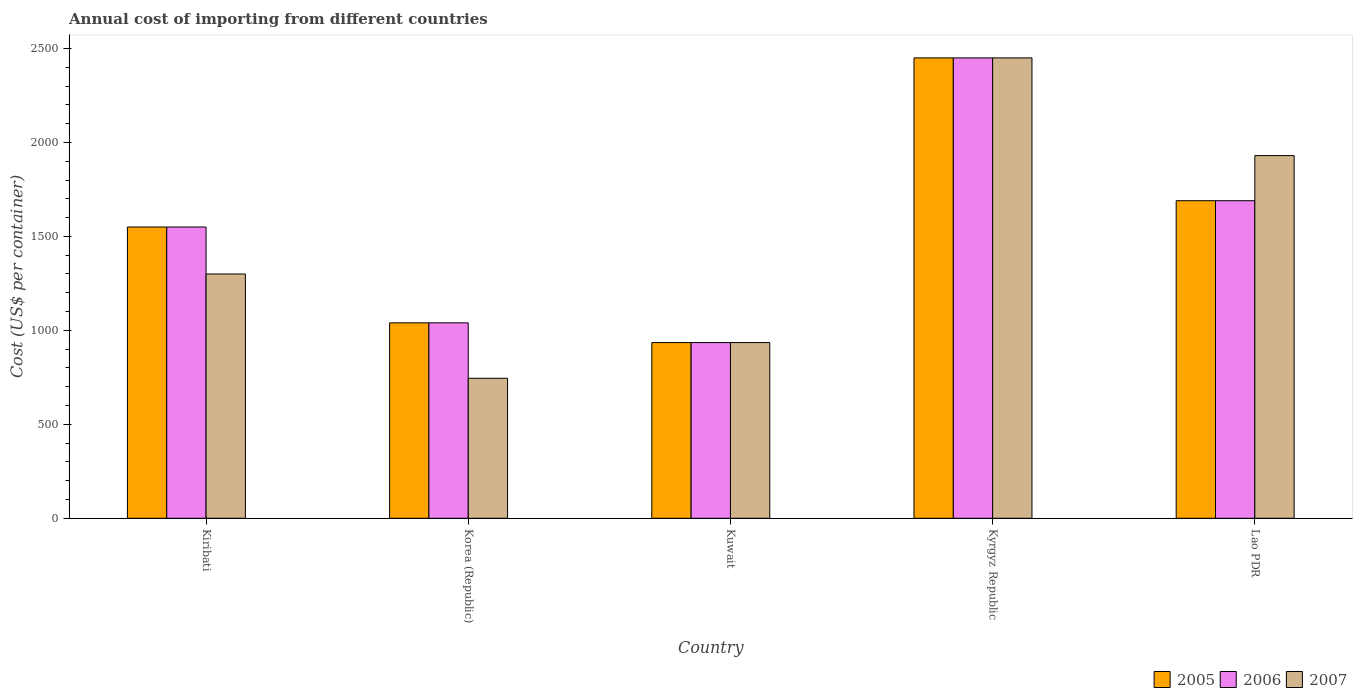How many different coloured bars are there?
Make the answer very short. 3. What is the total annual cost of importing in 2006 in Kyrgyz Republic?
Keep it short and to the point. 2450. Across all countries, what is the maximum total annual cost of importing in 2007?
Your answer should be compact. 2450. Across all countries, what is the minimum total annual cost of importing in 2006?
Provide a short and direct response. 935. In which country was the total annual cost of importing in 2007 maximum?
Ensure brevity in your answer.  Kyrgyz Republic. In which country was the total annual cost of importing in 2006 minimum?
Offer a very short reply. Kuwait. What is the total total annual cost of importing in 2007 in the graph?
Provide a succinct answer. 7360. What is the difference between the total annual cost of importing in 2006 in Korea (Republic) and that in Kuwait?
Make the answer very short. 105. What is the difference between the total annual cost of importing in 2006 in Kuwait and the total annual cost of importing in 2007 in Kiribati?
Give a very brief answer. -365. What is the average total annual cost of importing in 2005 per country?
Provide a succinct answer. 1533. What is the difference between the total annual cost of importing of/in 2006 and total annual cost of importing of/in 2005 in Kuwait?
Keep it short and to the point. 0. What is the ratio of the total annual cost of importing in 2007 in Kiribati to that in Korea (Republic)?
Offer a very short reply. 1.74. Is the difference between the total annual cost of importing in 2006 in Korea (Republic) and Kyrgyz Republic greater than the difference between the total annual cost of importing in 2005 in Korea (Republic) and Kyrgyz Republic?
Your response must be concise. No. What is the difference between the highest and the second highest total annual cost of importing in 2005?
Your answer should be very brief. 900. What is the difference between the highest and the lowest total annual cost of importing in 2005?
Make the answer very short. 1515. In how many countries, is the total annual cost of importing in 2007 greater than the average total annual cost of importing in 2007 taken over all countries?
Your answer should be compact. 2. How many legend labels are there?
Provide a short and direct response. 3. How are the legend labels stacked?
Make the answer very short. Horizontal. What is the title of the graph?
Your response must be concise. Annual cost of importing from different countries. Does "1961" appear as one of the legend labels in the graph?
Your answer should be compact. No. What is the label or title of the Y-axis?
Ensure brevity in your answer.  Cost (US$ per container). What is the Cost (US$ per container) in 2005 in Kiribati?
Your answer should be very brief. 1550. What is the Cost (US$ per container) in 2006 in Kiribati?
Provide a short and direct response. 1550. What is the Cost (US$ per container) in 2007 in Kiribati?
Keep it short and to the point. 1300. What is the Cost (US$ per container) in 2005 in Korea (Republic)?
Keep it short and to the point. 1040. What is the Cost (US$ per container) of 2006 in Korea (Republic)?
Offer a very short reply. 1040. What is the Cost (US$ per container) of 2007 in Korea (Republic)?
Keep it short and to the point. 745. What is the Cost (US$ per container) of 2005 in Kuwait?
Give a very brief answer. 935. What is the Cost (US$ per container) of 2006 in Kuwait?
Keep it short and to the point. 935. What is the Cost (US$ per container) of 2007 in Kuwait?
Your answer should be compact. 935. What is the Cost (US$ per container) of 2005 in Kyrgyz Republic?
Offer a very short reply. 2450. What is the Cost (US$ per container) in 2006 in Kyrgyz Republic?
Ensure brevity in your answer.  2450. What is the Cost (US$ per container) in 2007 in Kyrgyz Republic?
Your answer should be compact. 2450. What is the Cost (US$ per container) of 2005 in Lao PDR?
Offer a very short reply. 1690. What is the Cost (US$ per container) of 2006 in Lao PDR?
Provide a short and direct response. 1690. What is the Cost (US$ per container) in 2007 in Lao PDR?
Your answer should be compact. 1930. Across all countries, what is the maximum Cost (US$ per container) of 2005?
Offer a terse response. 2450. Across all countries, what is the maximum Cost (US$ per container) of 2006?
Provide a short and direct response. 2450. Across all countries, what is the maximum Cost (US$ per container) of 2007?
Provide a short and direct response. 2450. Across all countries, what is the minimum Cost (US$ per container) in 2005?
Your response must be concise. 935. Across all countries, what is the minimum Cost (US$ per container) in 2006?
Your answer should be very brief. 935. Across all countries, what is the minimum Cost (US$ per container) of 2007?
Keep it short and to the point. 745. What is the total Cost (US$ per container) of 2005 in the graph?
Keep it short and to the point. 7665. What is the total Cost (US$ per container) of 2006 in the graph?
Make the answer very short. 7665. What is the total Cost (US$ per container) in 2007 in the graph?
Offer a very short reply. 7360. What is the difference between the Cost (US$ per container) of 2005 in Kiribati and that in Korea (Republic)?
Your response must be concise. 510. What is the difference between the Cost (US$ per container) of 2006 in Kiribati and that in Korea (Republic)?
Your answer should be very brief. 510. What is the difference between the Cost (US$ per container) in 2007 in Kiribati and that in Korea (Republic)?
Your response must be concise. 555. What is the difference between the Cost (US$ per container) in 2005 in Kiribati and that in Kuwait?
Ensure brevity in your answer.  615. What is the difference between the Cost (US$ per container) in 2006 in Kiribati and that in Kuwait?
Keep it short and to the point. 615. What is the difference between the Cost (US$ per container) of 2007 in Kiribati and that in Kuwait?
Offer a very short reply. 365. What is the difference between the Cost (US$ per container) in 2005 in Kiribati and that in Kyrgyz Republic?
Your answer should be compact. -900. What is the difference between the Cost (US$ per container) of 2006 in Kiribati and that in Kyrgyz Republic?
Provide a succinct answer. -900. What is the difference between the Cost (US$ per container) in 2007 in Kiribati and that in Kyrgyz Republic?
Ensure brevity in your answer.  -1150. What is the difference between the Cost (US$ per container) of 2005 in Kiribati and that in Lao PDR?
Provide a short and direct response. -140. What is the difference between the Cost (US$ per container) in 2006 in Kiribati and that in Lao PDR?
Ensure brevity in your answer.  -140. What is the difference between the Cost (US$ per container) in 2007 in Kiribati and that in Lao PDR?
Ensure brevity in your answer.  -630. What is the difference between the Cost (US$ per container) in 2005 in Korea (Republic) and that in Kuwait?
Your answer should be very brief. 105. What is the difference between the Cost (US$ per container) in 2006 in Korea (Republic) and that in Kuwait?
Offer a very short reply. 105. What is the difference between the Cost (US$ per container) of 2007 in Korea (Republic) and that in Kuwait?
Offer a terse response. -190. What is the difference between the Cost (US$ per container) of 2005 in Korea (Republic) and that in Kyrgyz Republic?
Make the answer very short. -1410. What is the difference between the Cost (US$ per container) in 2006 in Korea (Republic) and that in Kyrgyz Republic?
Offer a terse response. -1410. What is the difference between the Cost (US$ per container) of 2007 in Korea (Republic) and that in Kyrgyz Republic?
Ensure brevity in your answer.  -1705. What is the difference between the Cost (US$ per container) in 2005 in Korea (Republic) and that in Lao PDR?
Keep it short and to the point. -650. What is the difference between the Cost (US$ per container) of 2006 in Korea (Republic) and that in Lao PDR?
Make the answer very short. -650. What is the difference between the Cost (US$ per container) in 2007 in Korea (Republic) and that in Lao PDR?
Keep it short and to the point. -1185. What is the difference between the Cost (US$ per container) of 2005 in Kuwait and that in Kyrgyz Republic?
Ensure brevity in your answer.  -1515. What is the difference between the Cost (US$ per container) in 2006 in Kuwait and that in Kyrgyz Republic?
Give a very brief answer. -1515. What is the difference between the Cost (US$ per container) in 2007 in Kuwait and that in Kyrgyz Republic?
Provide a short and direct response. -1515. What is the difference between the Cost (US$ per container) of 2005 in Kuwait and that in Lao PDR?
Give a very brief answer. -755. What is the difference between the Cost (US$ per container) of 2006 in Kuwait and that in Lao PDR?
Your answer should be very brief. -755. What is the difference between the Cost (US$ per container) in 2007 in Kuwait and that in Lao PDR?
Offer a very short reply. -995. What is the difference between the Cost (US$ per container) of 2005 in Kyrgyz Republic and that in Lao PDR?
Offer a terse response. 760. What is the difference between the Cost (US$ per container) in 2006 in Kyrgyz Republic and that in Lao PDR?
Your answer should be compact. 760. What is the difference between the Cost (US$ per container) of 2007 in Kyrgyz Republic and that in Lao PDR?
Your answer should be compact. 520. What is the difference between the Cost (US$ per container) in 2005 in Kiribati and the Cost (US$ per container) in 2006 in Korea (Republic)?
Provide a short and direct response. 510. What is the difference between the Cost (US$ per container) of 2005 in Kiribati and the Cost (US$ per container) of 2007 in Korea (Republic)?
Provide a succinct answer. 805. What is the difference between the Cost (US$ per container) of 2006 in Kiribati and the Cost (US$ per container) of 2007 in Korea (Republic)?
Your answer should be compact. 805. What is the difference between the Cost (US$ per container) of 2005 in Kiribati and the Cost (US$ per container) of 2006 in Kuwait?
Offer a terse response. 615. What is the difference between the Cost (US$ per container) in 2005 in Kiribati and the Cost (US$ per container) in 2007 in Kuwait?
Keep it short and to the point. 615. What is the difference between the Cost (US$ per container) in 2006 in Kiribati and the Cost (US$ per container) in 2007 in Kuwait?
Provide a short and direct response. 615. What is the difference between the Cost (US$ per container) of 2005 in Kiribati and the Cost (US$ per container) of 2006 in Kyrgyz Republic?
Provide a succinct answer. -900. What is the difference between the Cost (US$ per container) of 2005 in Kiribati and the Cost (US$ per container) of 2007 in Kyrgyz Republic?
Offer a very short reply. -900. What is the difference between the Cost (US$ per container) of 2006 in Kiribati and the Cost (US$ per container) of 2007 in Kyrgyz Republic?
Offer a terse response. -900. What is the difference between the Cost (US$ per container) in 2005 in Kiribati and the Cost (US$ per container) in 2006 in Lao PDR?
Your response must be concise. -140. What is the difference between the Cost (US$ per container) of 2005 in Kiribati and the Cost (US$ per container) of 2007 in Lao PDR?
Your response must be concise. -380. What is the difference between the Cost (US$ per container) of 2006 in Kiribati and the Cost (US$ per container) of 2007 in Lao PDR?
Give a very brief answer. -380. What is the difference between the Cost (US$ per container) of 2005 in Korea (Republic) and the Cost (US$ per container) of 2006 in Kuwait?
Your response must be concise. 105. What is the difference between the Cost (US$ per container) of 2005 in Korea (Republic) and the Cost (US$ per container) of 2007 in Kuwait?
Ensure brevity in your answer.  105. What is the difference between the Cost (US$ per container) in 2006 in Korea (Republic) and the Cost (US$ per container) in 2007 in Kuwait?
Keep it short and to the point. 105. What is the difference between the Cost (US$ per container) of 2005 in Korea (Republic) and the Cost (US$ per container) of 2006 in Kyrgyz Republic?
Provide a short and direct response. -1410. What is the difference between the Cost (US$ per container) of 2005 in Korea (Republic) and the Cost (US$ per container) of 2007 in Kyrgyz Republic?
Give a very brief answer. -1410. What is the difference between the Cost (US$ per container) of 2006 in Korea (Republic) and the Cost (US$ per container) of 2007 in Kyrgyz Republic?
Provide a short and direct response. -1410. What is the difference between the Cost (US$ per container) of 2005 in Korea (Republic) and the Cost (US$ per container) of 2006 in Lao PDR?
Your response must be concise. -650. What is the difference between the Cost (US$ per container) of 2005 in Korea (Republic) and the Cost (US$ per container) of 2007 in Lao PDR?
Keep it short and to the point. -890. What is the difference between the Cost (US$ per container) of 2006 in Korea (Republic) and the Cost (US$ per container) of 2007 in Lao PDR?
Provide a succinct answer. -890. What is the difference between the Cost (US$ per container) in 2005 in Kuwait and the Cost (US$ per container) in 2006 in Kyrgyz Republic?
Ensure brevity in your answer.  -1515. What is the difference between the Cost (US$ per container) of 2005 in Kuwait and the Cost (US$ per container) of 2007 in Kyrgyz Republic?
Your answer should be compact. -1515. What is the difference between the Cost (US$ per container) of 2006 in Kuwait and the Cost (US$ per container) of 2007 in Kyrgyz Republic?
Your answer should be very brief. -1515. What is the difference between the Cost (US$ per container) of 2005 in Kuwait and the Cost (US$ per container) of 2006 in Lao PDR?
Provide a succinct answer. -755. What is the difference between the Cost (US$ per container) in 2005 in Kuwait and the Cost (US$ per container) in 2007 in Lao PDR?
Provide a succinct answer. -995. What is the difference between the Cost (US$ per container) of 2006 in Kuwait and the Cost (US$ per container) of 2007 in Lao PDR?
Provide a short and direct response. -995. What is the difference between the Cost (US$ per container) of 2005 in Kyrgyz Republic and the Cost (US$ per container) of 2006 in Lao PDR?
Your response must be concise. 760. What is the difference between the Cost (US$ per container) in 2005 in Kyrgyz Republic and the Cost (US$ per container) in 2007 in Lao PDR?
Provide a succinct answer. 520. What is the difference between the Cost (US$ per container) in 2006 in Kyrgyz Republic and the Cost (US$ per container) in 2007 in Lao PDR?
Offer a very short reply. 520. What is the average Cost (US$ per container) of 2005 per country?
Ensure brevity in your answer.  1533. What is the average Cost (US$ per container) in 2006 per country?
Make the answer very short. 1533. What is the average Cost (US$ per container) of 2007 per country?
Give a very brief answer. 1472. What is the difference between the Cost (US$ per container) in 2005 and Cost (US$ per container) in 2006 in Kiribati?
Make the answer very short. 0. What is the difference between the Cost (US$ per container) in 2005 and Cost (US$ per container) in 2007 in Kiribati?
Ensure brevity in your answer.  250. What is the difference between the Cost (US$ per container) in 2006 and Cost (US$ per container) in 2007 in Kiribati?
Provide a succinct answer. 250. What is the difference between the Cost (US$ per container) of 2005 and Cost (US$ per container) of 2007 in Korea (Republic)?
Make the answer very short. 295. What is the difference between the Cost (US$ per container) of 2006 and Cost (US$ per container) of 2007 in Korea (Republic)?
Offer a terse response. 295. What is the difference between the Cost (US$ per container) in 2005 and Cost (US$ per container) in 2006 in Kuwait?
Make the answer very short. 0. What is the difference between the Cost (US$ per container) of 2005 and Cost (US$ per container) of 2007 in Kuwait?
Make the answer very short. 0. What is the difference between the Cost (US$ per container) in 2006 and Cost (US$ per container) in 2007 in Kuwait?
Offer a terse response. 0. What is the difference between the Cost (US$ per container) in 2005 and Cost (US$ per container) in 2007 in Kyrgyz Republic?
Give a very brief answer. 0. What is the difference between the Cost (US$ per container) in 2005 and Cost (US$ per container) in 2007 in Lao PDR?
Provide a short and direct response. -240. What is the difference between the Cost (US$ per container) in 2006 and Cost (US$ per container) in 2007 in Lao PDR?
Offer a very short reply. -240. What is the ratio of the Cost (US$ per container) in 2005 in Kiribati to that in Korea (Republic)?
Your answer should be very brief. 1.49. What is the ratio of the Cost (US$ per container) of 2006 in Kiribati to that in Korea (Republic)?
Provide a short and direct response. 1.49. What is the ratio of the Cost (US$ per container) of 2007 in Kiribati to that in Korea (Republic)?
Your answer should be very brief. 1.75. What is the ratio of the Cost (US$ per container) of 2005 in Kiribati to that in Kuwait?
Offer a terse response. 1.66. What is the ratio of the Cost (US$ per container) in 2006 in Kiribati to that in Kuwait?
Your answer should be compact. 1.66. What is the ratio of the Cost (US$ per container) of 2007 in Kiribati to that in Kuwait?
Give a very brief answer. 1.39. What is the ratio of the Cost (US$ per container) of 2005 in Kiribati to that in Kyrgyz Republic?
Your answer should be compact. 0.63. What is the ratio of the Cost (US$ per container) of 2006 in Kiribati to that in Kyrgyz Republic?
Your answer should be compact. 0.63. What is the ratio of the Cost (US$ per container) in 2007 in Kiribati to that in Kyrgyz Republic?
Ensure brevity in your answer.  0.53. What is the ratio of the Cost (US$ per container) in 2005 in Kiribati to that in Lao PDR?
Your response must be concise. 0.92. What is the ratio of the Cost (US$ per container) of 2006 in Kiribati to that in Lao PDR?
Your response must be concise. 0.92. What is the ratio of the Cost (US$ per container) in 2007 in Kiribati to that in Lao PDR?
Offer a very short reply. 0.67. What is the ratio of the Cost (US$ per container) in 2005 in Korea (Republic) to that in Kuwait?
Your response must be concise. 1.11. What is the ratio of the Cost (US$ per container) in 2006 in Korea (Republic) to that in Kuwait?
Ensure brevity in your answer.  1.11. What is the ratio of the Cost (US$ per container) in 2007 in Korea (Republic) to that in Kuwait?
Provide a succinct answer. 0.8. What is the ratio of the Cost (US$ per container) in 2005 in Korea (Republic) to that in Kyrgyz Republic?
Make the answer very short. 0.42. What is the ratio of the Cost (US$ per container) of 2006 in Korea (Republic) to that in Kyrgyz Republic?
Provide a succinct answer. 0.42. What is the ratio of the Cost (US$ per container) in 2007 in Korea (Republic) to that in Kyrgyz Republic?
Give a very brief answer. 0.3. What is the ratio of the Cost (US$ per container) in 2005 in Korea (Republic) to that in Lao PDR?
Your answer should be compact. 0.62. What is the ratio of the Cost (US$ per container) of 2006 in Korea (Republic) to that in Lao PDR?
Ensure brevity in your answer.  0.62. What is the ratio of the Cost (US$ per container) in 2007 in Korea (Republic) to that in Lao PDR?
Your answer should be very brief. 0.39. What is the ratio of the Cost (US$ per container) of 2005 in Kuwait to that in Kyrgyz Republic?
Provide a short and direct response. 0.38. What is the ratio of the Cost (US$ per container) of 2006 in Kuwait to that in Kyrgyz Republic?
Your answer should be very brief. 0.38. What is the ratio of the Cost (US$ per container) of 2007 in Kuwait to that in Kyrgyz Republic?
Ensure brevity in your answer.  0.38. What is the ratio of the Cost (US$ per container) in 2005 in Kuwait to that in Lao PDR?
Provide a short and direct response. 0.55. What is the ratio of the Cost (US$ per container) of 2006 in Kuwait to that in Lao PDR?
Offer a terse response. 0.55. What is the ratio of the Cost (US$ per container) of 2007 in Kuwait to that in Lao PDR?
Offer a terse response. 0.48. What is the ratio of the Cost (US$ per container) of 2005 in Kyrgyz Republic to that in Lao PDR?
Keep it short and to the point. 1.45. What is the ratio of the Cost (US$ per container) in 2006 in Kyrgyz Republic to that in Lao PDR?
Keep it short and to the point. 1.45. What is the ratio of the Cost (US$ per container) of 2007 in Kyrgyz Republic to that in Lao PDR?
Make the answer very short. 1.27. What is the difference between the highest and the second highest Cost (US$ per container) of 2005?
Your response must be concise. 760. What is the difference between the highest and the second highest Cost (US$ per container) in 2006?
Keep it short and to the point. 760. What is the difference between the highest and the second highest Cost (US$ per container) of 2007?
Provide a short and direct response. 520. What is the difference between the highest and the lowest Cost (US$ per container) in 2005?
Your answer should be compact. 1515. What is the difference between the highest and the lowest Cost (US$ per container) in 2006?
Ensure brevity in your answer.  1515. What is the difference between the highest and the lowest Cost (US$ per container) of 2007?
Your response must be concise. 1705. 